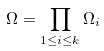Convert formula to latex. <formula><loc_0><loc_0><loc_500><loc_500>\Omega = \prod _ { 1 \leq i \leq k } \Omega _ { i }</formula> 